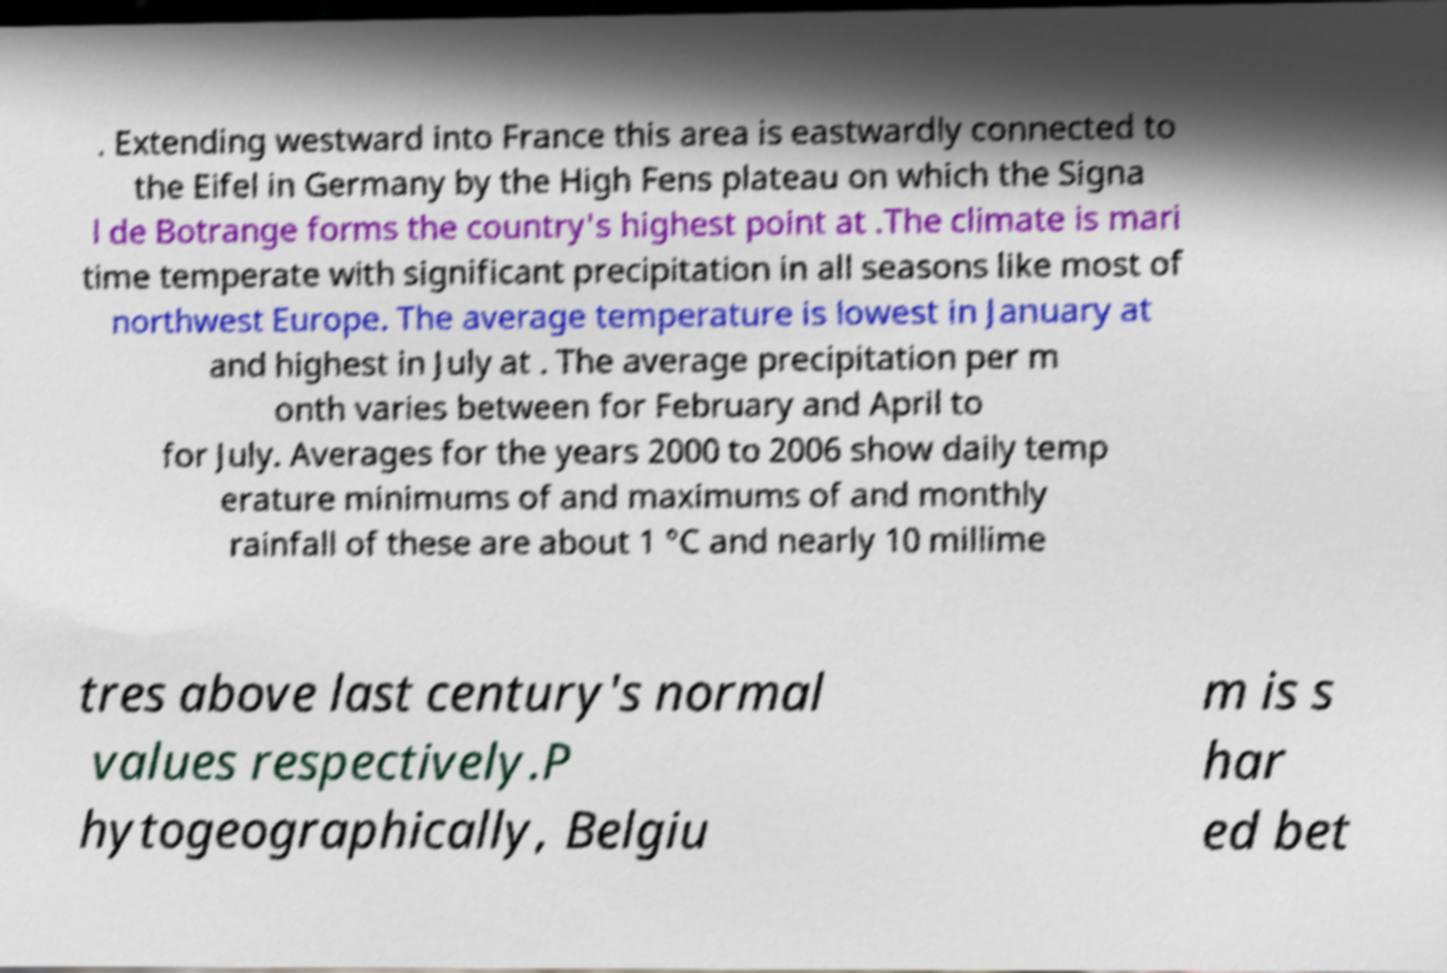Can you read and provide the text displayed in the image?This photo seems to have some interesting text. Can you extract and type it out for me? . Extending westward into France this area is eastwardly connected to the Eifel in Germany by the High Fens plateau on which the Signa l de Botrange forms the country's highest point at .The climate is mari time temperate with significant precipitation in all seasons like most of northwest Europe. The average temperature is lowest in January at and highest in July at . The average precipitation per m onth varies between for February and April to for July. Averages for the years 2000 to 2006 show daily temp erature minimums of and maximums of and monthly rainfall of these are about 1 °C and nearly 10 millime tres above last century's normal values respectively.P hytogeographically, Belgiu m is s har ed bet 